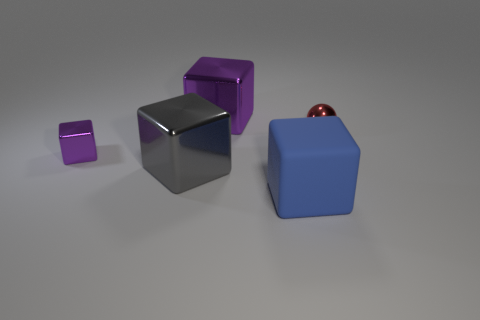What materials are the objects in the image made of? The objects in the image appear to be made of different materials. The two blocks on the left appear to have a metallic finish, possibly indicating they are made of metal. The big block on the right has a matte surface, suggesting it could be made of rubber. There's also a small spherical object that seems to have a reflective surface, which might indicate it's made of glass or polished metal. 